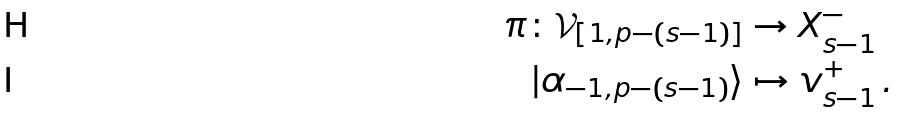Convert formula to latex. <formula><loc_0><loc_0><loc_500><loc_500>\pi \colon \mathcal { V } _ { [ 1 , p - ( s - 1 ) ] } & \rightarrow X _ { s - 1 } ^ { - } \\ | \alpha _ { - 1 , p - ( s - 1 ) } \rangle & \mapsto v _ { s - 1 } ^ { + } \, .</formula> 